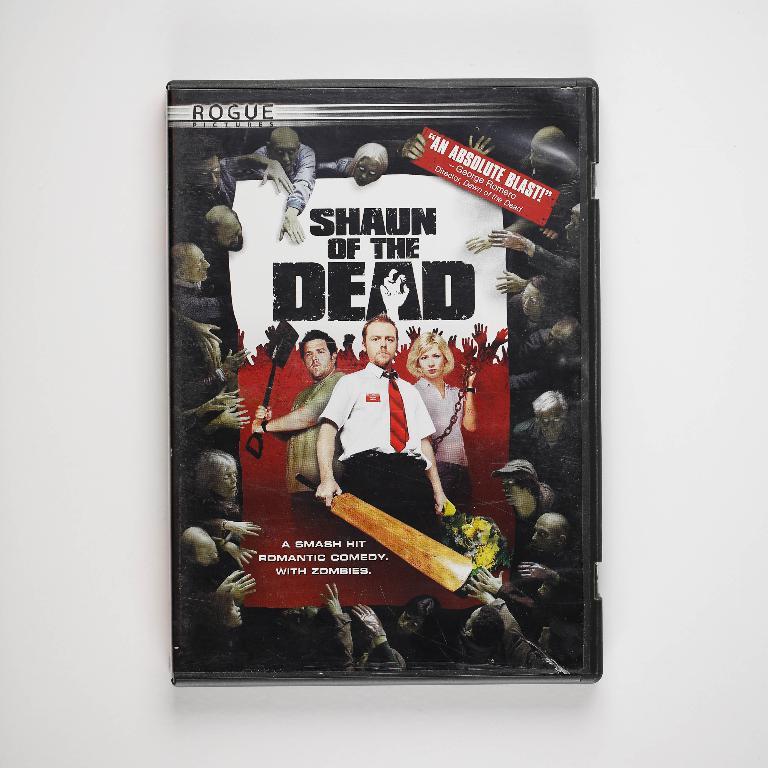What funny zombie movie title is shown on this cover?
Offer a very short reply. Shaun of the dead. Who said this movie is an absolute blast?
Your answer should be compact. George romero. 